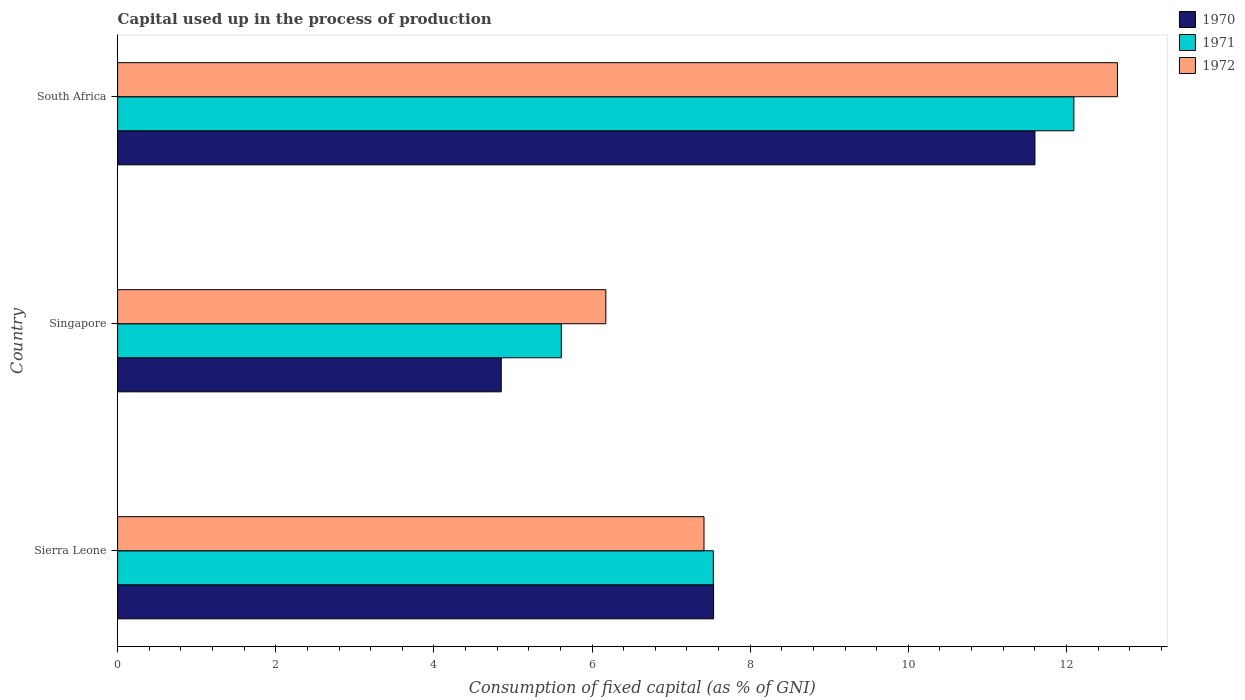Are the number of bars per tick equal to the number of legend labels?
Provide a short and direct response. Yes. What is the label of the 3rd group of bars from the top?
Your response must be concise. Sierra Leone. What is the capital used up in the process of production in 1970 in Sierra Leone?
Provide a short and direct response. 7.54. Across all countries, what is the maximum capital used up in the process of production in 1972?
Offer a very short reply. 12.65. Across all countries, what is the minimum capital used up in the process of production in 1972?
Provide a short and direct response. 6.18. In which country was the capital used up in the process of production in 1971 maximum?
Provide a short and direct response. South Africa. In which country was the capital used up in the process of production in 1971 minimum?
Offer a very short reply. Singapore. What is the total capital used up in the process of production in 1971 in the graph?
Keep it short and to the point. 25.24. What is the difference between the capital used up in the process of production in 1971 in Sierra Leone and that in South Africa?
Give a very brief answer. -4.56. What is the difference between the capital used up in the process of production in 1972 in Sierra Leone and the capital used up in the process of production in 1970 in South Africa?
Provide a short and direct response. -4.19. What is the average capital used up in the process of production in 1972 per country?
Make the answer very short. 8.75. What is the difference between the capital used up in the process of production in 1970 and capital used up in the process of production in 1972 in South Africa?
Keep it short and to the point. -1.04. In how many countries, is the capital used up in the process of production in 1971 greater than 10.4 %?
Give a very brief answer. 1. What is the ratio of the capital used up in the process of production in 1972 in Singapore to that in South Africa?
Give a very brief answer. 0.49. Is the difference between the capital used up in the process of production in 1970 in Singapore and South Africa greater than the difference between the capital used up in the process of production in 1972 in Singapore and South Africa?
Give a very brief answer. No. What is the difference between the highest and the second highest capital used up in the process of production in 1971?
Offer a very short reply. 4.56. What is the difference between the highest and the lowest capital used up in the process of production in 1972?
Your response must be concise. 6.47. What does the 2nd bar from the top in Singapore represents?
Keep it short and to the point. 1971. Are all the bars in the graph horizontal?
Your response must be concise. Yes. What is the difference between two consecutive major ticks on the X-axis?
Your answer should be compact. 2. Where does the legend appear in the graph?
Offer a very short reply. Top right. How many legend labels are there?
Offer a terse response. 3. What is the title of the graph?
Your answer should be very brief. Capital used up in the process of production. What is the label or title of the X-axis?
Make the answer very short. Consumption of fixed capital (as % of GNI). What is the label or title of the Y-axis?
Your answer should be very brief. Country. What is the Consumption of fixed capital (as % of GNI) of 1970 in Sierra Leone?
Keep it short and to the point. 7.54. What is the Consumption of fixed capital (as % of GNI) in 1971 in Sierra Leone?
Offer a very short reply. 7.53. What is the Consumption of fixed capital (as % of GNI) of 1972 in Sierra Leone?
Offer a very short reply. 7.42. What is the Consumption of fixed capital (as % of GNI) in 1970 in Singapore?
Make the answer very short. 4.85. What is the Consumption of fixed capital (as % of GNI) of 1971 in Singapore?
Your response must be concise. 5.61. What is the Consumption of fixed capital (as % of GNI) in 1972 in Singapore?
Keep it short and to the point. 6.18. What is the Consumption of fixed capital (as % of GNI) of 1970 in South Africa?
Offer a very short reply. 11.6. What is the Consumption of fixed capital (as % of GNI) in 1971 in South Africa?
Give a very brief answer. 12.09. What is the Consumption of fixed capital (as % of GNI) of 1972 in South Africa?
Make the answer very short. 12.65. Across all countries, what is the maximum Consumption of fixed capital (as % of GNI) of 1970?
Your answer should be compact. 11.6. Across all countries, what is the maximum Consumption of fixed capital (as % of GNI) of 1971?
Your answer should be compact. 12.09. Across all countries, what is the maximum Consumption of fixed capital (as % of GNI) of 1972?
Make the answer very short. 12.65. Across all countries, what is the minimum Consumption of fixed capital (as % of GNI) in 1970?
Your answer should be compact. 4.85. Across all countries, what is the minimum Consumption of fixed capital (as % of GNI) of 1971?
Give a very brief answer. 5.61. Across all countries, what is the minimum Consumption of fixed capital (as % of GNI) of 1972?
Keep it short and to the point. 6.18. What is the total Consumption of fixed capital (as % of GNI) in 1970 in the graph?
Provide a succinct answer. 23.99. What is the total Consumption of fixed capital (as % of GNI) of 1971 in the graph?
Offer a terse response. 25.24. What is the total Consumption of fixed capital (as % of GNI) of 1972 in the graph?
Keep it short and to the point. 26.24. What is the difference between the Consumption of fixed capital (as % of GNI) in 1970 in Sierra Leone and that in Singapore?
Your answer should be very brief. 2.69. What is the difference between the Consumption of fixed capital (as % of GNI) in 1971 in Sierra Leone and that in Singapore?
Offer a very short reply. 1.92. What is the difference between the Consumption of fixed capital (as % of GNI) of 1972 in Sierra Leone and that in Singapore?
Keep it short and to the point. 1.24. What is the difference between the Consumption of fixed capital (as % of GNI) of 1970 in Sierra Leone and that in South Africa?
Give a very brief answer. -4.06. What is the difference between the Consumption of fixed capital (as % of GNI) in 1971 in Sierra Leone and that in South Africa?
Offer a terse response. -4.56. What is the difference between the Consumption of fixed capital (as % of GNI) of 1972 in Sierra Leone and that in South Africa?
Make the answer very short. -5.23. What is the difference between the Consumption of fixed capital (as % of GNI) in 1970 in Singapore and that in South Africa?
Give a very brief answer. -6.75. What is the difference between the Consumption of fixed capital (as % of GNI) of 1971 in Singapore and that in South Africa?
Ensure brevity in your answer.  -6.48. What is the difference between the Consumption of fixed capital (as % of GNI) of 1972 in Singapore and that in South Africa?
Offer a very short reply. -6.47. What is the difference between the Consumption of fixed capital (as % of GNI) in 1970 in Sierra Leone and the Consumption of fixed capital (as % of GNI) in 1971 in Singapore?
Offer a very short reply. 1.93. What is the difference between the Consumption of fixed capital (as % of GNI) of 1970 in Sierra Leone and the Consumption of fixed capital (as % of GNI) of 1972 in Singapore?
Make the answer very short. 1.36. What is the difference between the Consumption of fixed capital (as % of GNI) of 1971 in Sierra Leone and the Consumption of fixed capital (as % of GNI) of 1972 in Singapore?
Offer a very short reply. 1.36. What is the difference between the Consumption of fixed capital (as % of GNI) of 1970 in Sierra Leone and the Consumption of fixed capital (as % of GNI) of 1971 in South Africa?
Offer a very short reply. -4.56. What is the difference between the Consumption of fixed capital (as % of GNI) in 1970 in Sierra Leone and the Consumption of fixed capital (as % of GNI) in 1972 in South Africa?
Give a very brief answer. -5.11. What is the difference between the Consumption of fixed capital (as % of GNI) in 1971 in Sierra Leone and the Consumption of fixed capital (as % of GNI) in 1972 in South Africa?
Ensure brevity in your answer.  -5.11. What is the difference between the Consumption of fixed capital (as % of GNI) of 1970 in Singapore and the Consumption of fixed capital (as % of GNI) of 1971 in South Africa?
Offer a terse response. -7.24. What is the difference between the Consumption of fixed capital (as % of GNI) of 1970 in Singapore and the Consumption of fixed capital (as % of GNI) of 1972 in South Africa?
Your answer should be very brief. -7.79. What is the difference between the Consumption of fixed capital (as % of GNI) in 1971 in Singapore and the Consumption of fixed capital (as % of GNI) in 1972 in South Africa?
Keep it short and to the point. -7.03. What is the average Consumption of fixed capital (as % of GNI) of 1970 per country?
Your response must be concise. 8. What is the average Consumption of fixed capital (as % of GNI) in 1971 per country?
Your answer should be very brief. 8.41. What is the average Consumption of fixed capital (as % of GNI) of 1972 per country?
Your answer should be compact. 8.75. What is the difference between the Consumption of fixed capital (as % of GNI) of 1970 and Consumption of fixed capital (as % of GNI) of 1971 in Sierra Leone?
Make the answer very short. 0. What is the difference between the Consumption of fixed capital (as % of GNI) of 1970 and Consumption of fixed capital (as % of GNI) of 1972 in Sierra Leone?
Offer a terse response. 0.12. What is the difference between the Consumption of fixed capital (as % of GNI) in 1971 and Consumption of fixed capital (as % of GNI) in 1972 in Sierra Leone?
Your response must be concise. 0.12. What is the difference between the Consumption of fixed capital (as % of GNI) of 1970 and Consumption of fixed capital (as % of GNI) of 1971 in Singapore?
Offer a very short reply. -0.76. What is the difference between the Consumption of fixed capital (as % of GNI) in 1970 and Consumption of fixed capital (as % of GNI) in 1972 in Singapore?
Offer a terse response. -1.32. What is the difference between the Consumption of fixed capital (as % of GNI) in 1971 and Consumption of fixed capital (as % of GNI) in 1972 in Singapore?
Offer a terse response. -0.56. What is the difference between the Consumption of fixed capital (as % of GNI) in 1970 and Consumption of fixed capital (as % of GNI) in 1971 in South Africa?
Provide a succinct answer. -0.49. What is the difference between the Consumption of fixed capital (as % of GNI) in 1970 and Consumption of fixed capital (as % of GNI) in 1972 in South Africa?
Give a very brief answer. -1.04. What is the difference between the Consumption of fixed capital (as % of GNI) of 1971 and Consumption of fixed capital (as % of GNI) of 1972 in South Africa?
Provide a succinct answer. -0.55. What is the ratio of the Consumption of fixed capital (as % of GNI) in 1970 in Sierra Leone to that in Singapore?
Keep it short and to the point. 1.55. What is the ratio of the Consumption of fixed capital (as % of GNI) of 1971 in Sierra Leone to that in Singapore?
Make the answer very short. 1.34. What is the ratio of the Consumption of fixed capital (as % of GNI) in 1972 in Sierra Leone to that in Singapore?
Offer a terse response. 1.2. What is the ratio of the Consumption of fixed capital (as % of GNI) of 1970 in Sierra Leone to that in South Africa?
Offer a terse response. 0.65. What is the ratio of the Consumption of fixed capital (as % of GNI) of 1971 in Sierra Leone to that in South Africa?
Offer a very short reply. 0.62. What is the ratio of the Consumption of fixed capital (as % of GNI) in 1972 in Sierra Leone to that in South Africa?
Your answer should be compact. 0.59. What is the ratio of the Consumption of fixed capital (as % of GNI) in 1970 in Singapore to that in South Africa?
Make the answer very short. 0.42. What is the ratio of the Consumption of fixed capital (as % of GNI) of 1971 in Singapore to that in South Africa?
Offer a terse response. 0.46. What is the ratio of the Consumption of fixed capital (as % of GNI) in 1972 in Singapore to that in South Africa?
Provide a short and direct response. 0.49. What is the difference between the highest and the second highest Consumption of fixed capital (as % of GNI) of 1970?
Provide a short and direct response. 4.06. What is the difference between the highest and the second highest Consumption of fixed capital (as % of GNI) of 1971?
Provide a succinct answer. 4.56. What is the difference between the highest and the second highest Consumption of fixed capital (as % of GNI) of 1972?
Keep it short and to the point. 5.23. What is the difference between the highest and the lowest Consumption of fixed capital (as % of GNI) of 1970?
Make the answer very short. 6.75. What is the difference between the highest and the lowest Consumption of fixed capital (as % of GNI) in 1971?
Your response must be concise. 6.48. What is the difference between the highest and the lowest Consumption of fixed capital (as % of GNI) in 1972?
Provide a short and direct response. 6.47. 